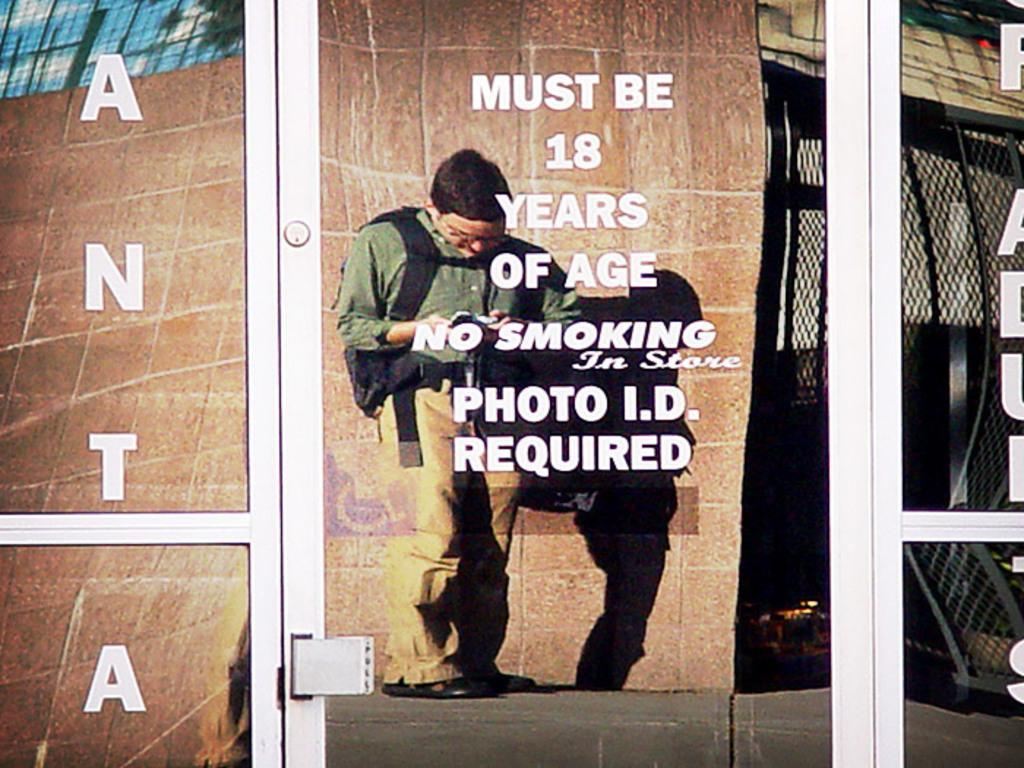Who is the main subject in the image? There is a person in the center of the image. What is the person wearing? The person is wearing a backpack. What is the person holding? The person is holding an object. What is the person standing on? The person is standing on the ground. What other elements can be seen in the image? There is a cable, a net, a door, and text present in the image. What type of stocking is the person wearing in the image? There is no mention of stockings in the image, so it cannot be determined if the person is wearing any. Can you describe the garden visible in the image? There is no garden present in the image. 